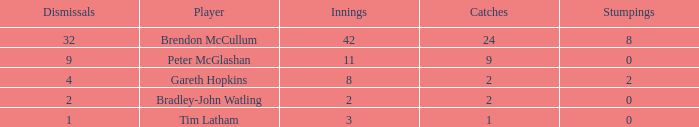How many dismissals did the player Peter McGlashan have? 9.0. 